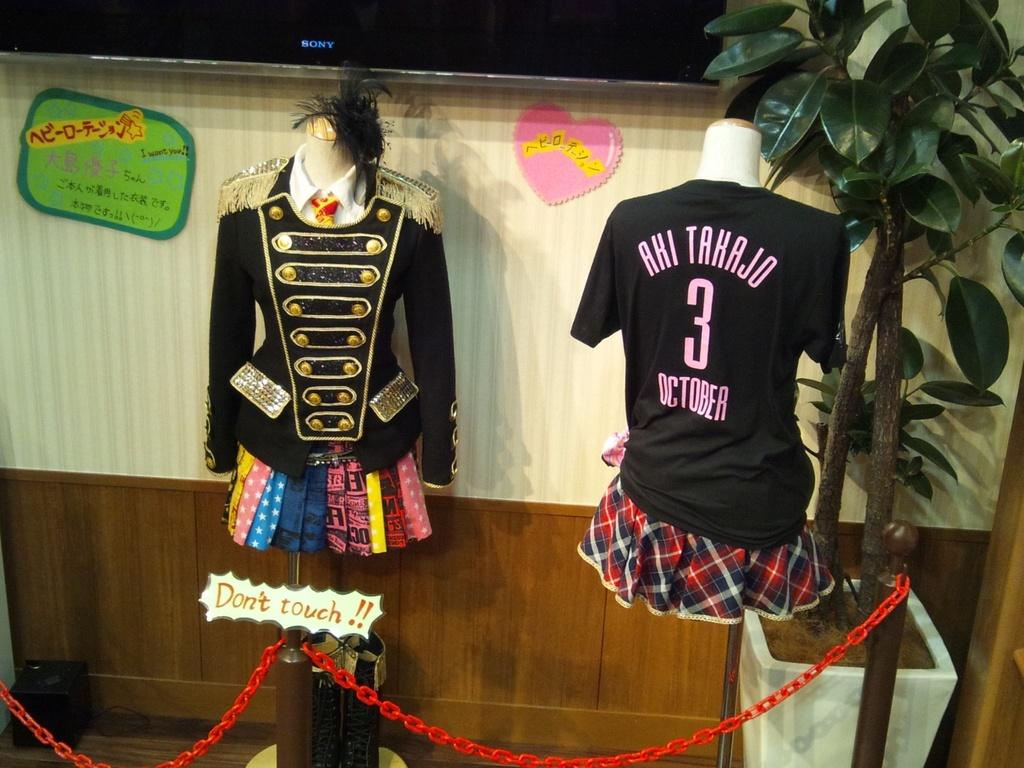<image>
Present a compact description of the photo's key features. a shirt with the number 3 on it 